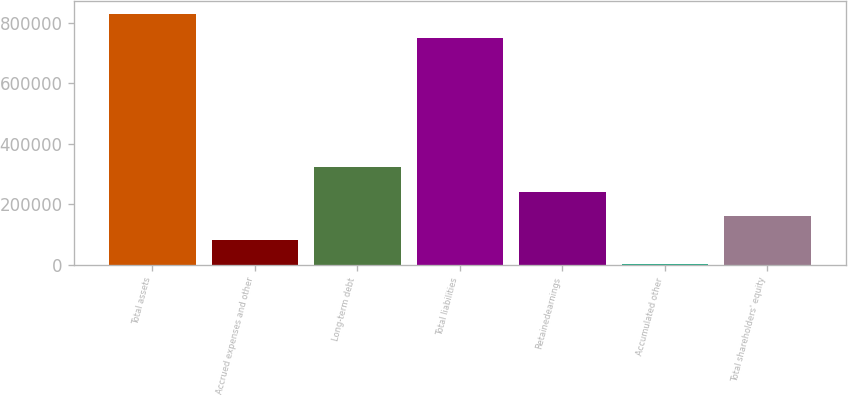Convert chart. <chart><loc_0><loc_0><loc_500><loc_500><bar_chart><fcel>Total assets<fcel>Accrued expenses and other<fcel>Long-term debt<fcel>Total liabilities<fcel>Retainedearnings<fcel>Accumulated other<fcel>Total shareholders' equity<nl><fcel>830921<fcel>82466.1<fcel>321635<fcel>751198<fcel>241912<fcel>2743<fcel>162189<nl></chart> 